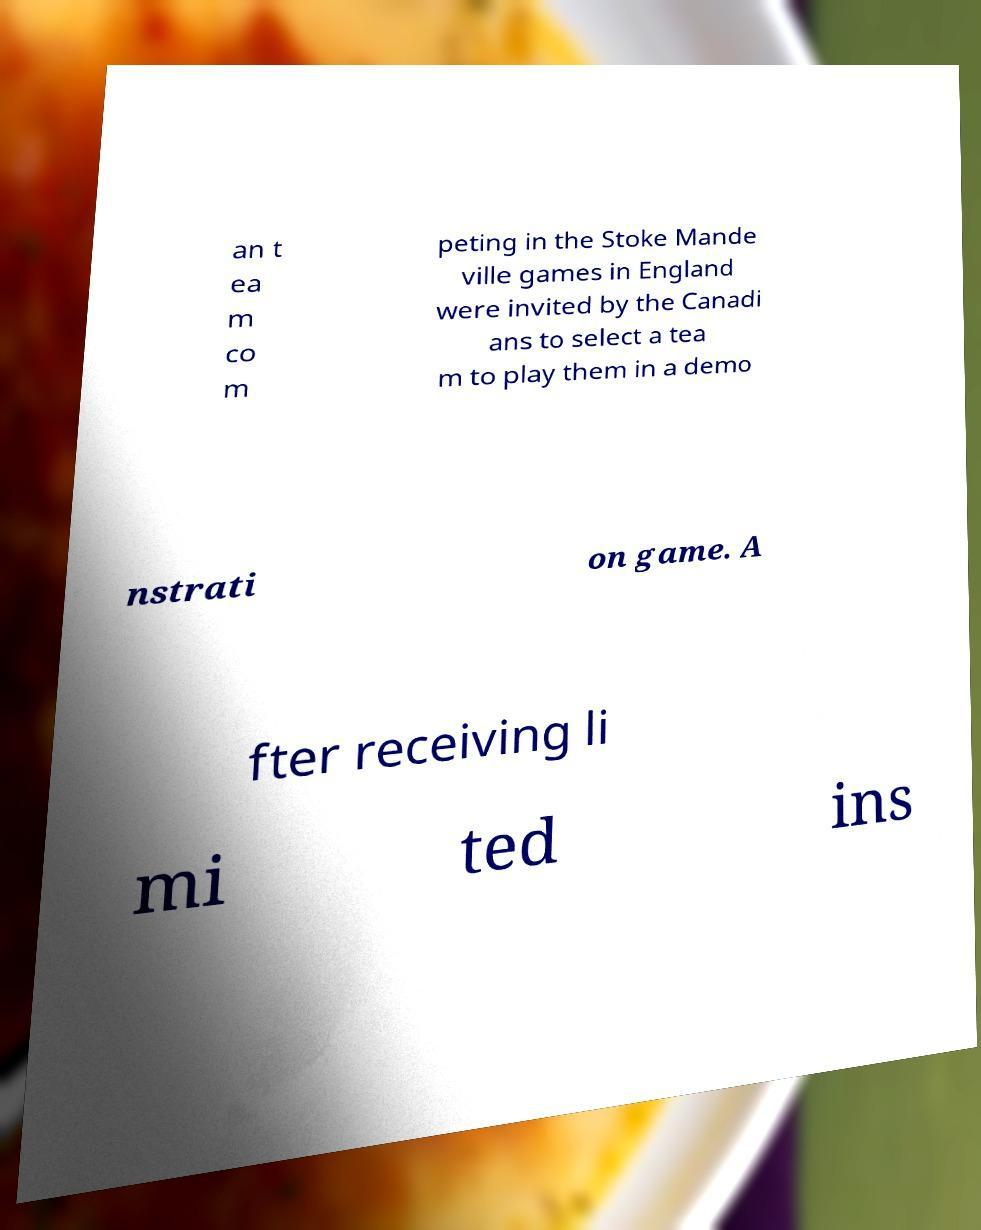Could you extract and type out the text from this image? an t ea m co m peting in the Stoke Mande ville games in England were invited by the Canadi ans to select a tea m to play them in a demo nstrati on game. A fter receiving li mi ted ins 